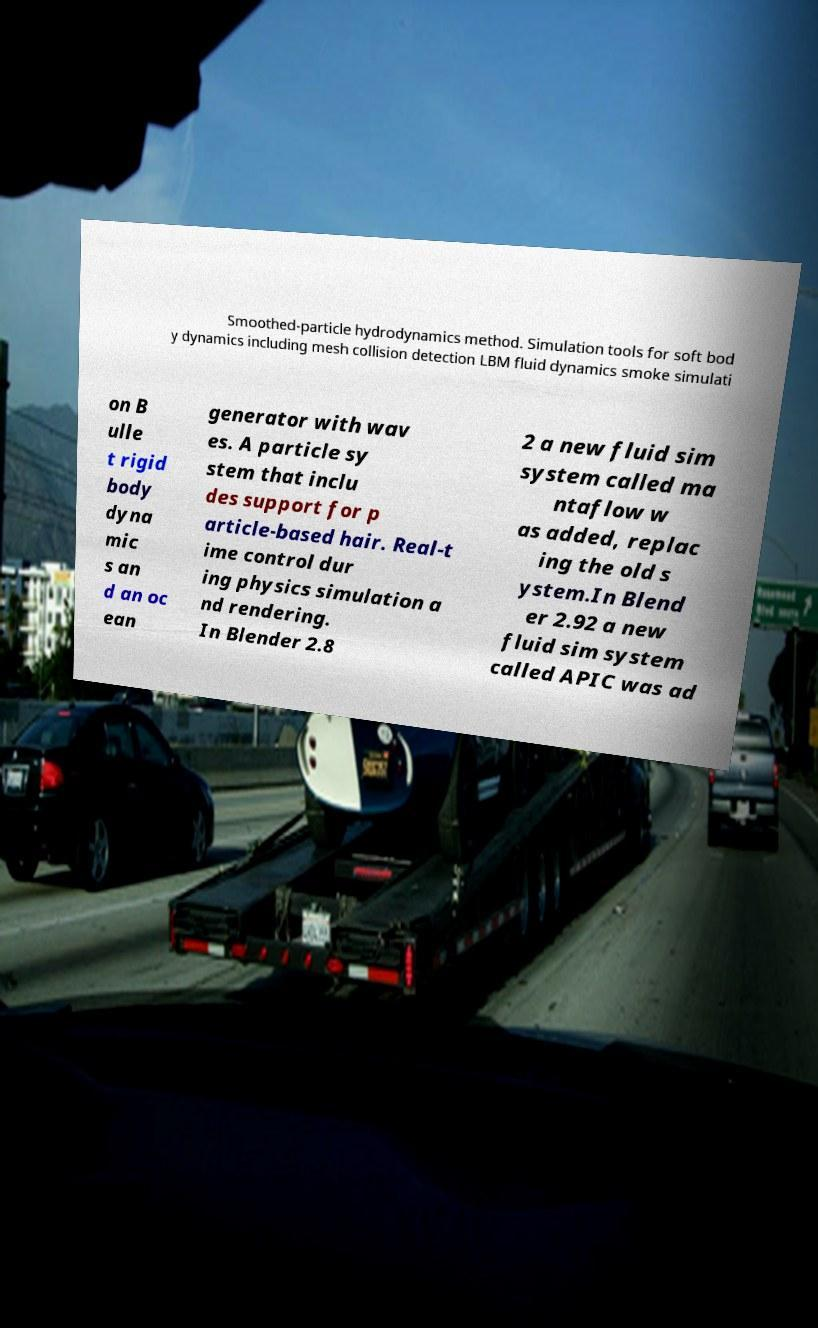For documentation purposes, I need the text within this image transcribed. Could you provide that? Smoothed-particle hydrodynamics method. Simulation tools for soft bod y dynamics including mesh collision detection LBM fluid dynamics smoke simulati on B ulle t rigid body dyna mic s an d an oc ean generator with wav es. A particle sy stem that inclu des support for p article-based hair. Real-t ime control dur ing physics simulation a nd rendering. In Blender 2.8 2 a new fluid sim system called ma ntaflow w as added, replac ing the old s ystem.In Blend er 2.92 a new fluid sim system called APIC was ad 